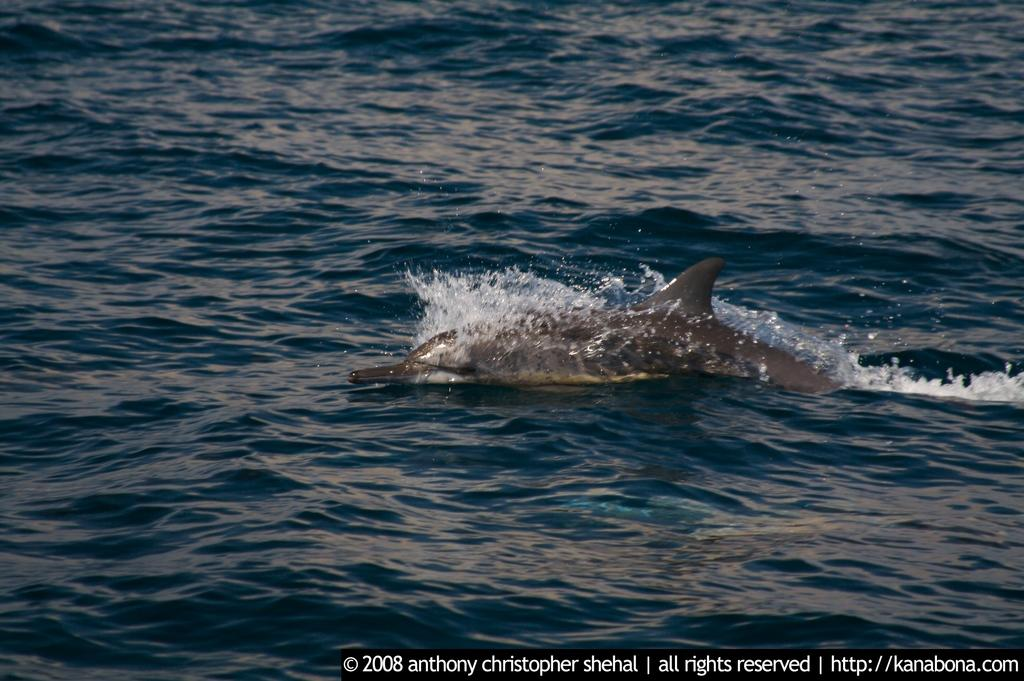What can be seen in the image that indicates it is a document or image file? There is a watermark in the image. What information is located at the bottom of the image? There is text and numbers at the bottom of the image. What type of creature can be seen in the water in the image? There is a sea animal visible in the water. What type of wheel can be seen in the image? There is no wheel present in the image. What songs are being sung by the sea animal in the image? There is no indication that the sea animal is singing any songs in the image. 